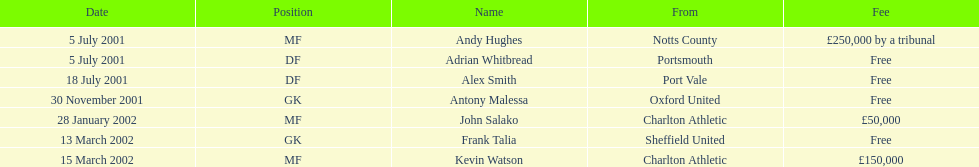Who shifted before 1 august 2001? Andy Hughes, Adrian Whitbread, Alex Smith. Would you be able to parse every entry in this table? {'header': ['Date', 'Position', 'Name', 'From', 'Fee'], 'rows': [['5 July 2001', 'MF', 'Andy Hughes', 'Notts County', '£250,000 by a tribunal'], ['5 July 2001', 'DF', 'Adrian Whitbread', 'Portsmouth', 'Free'], ['18 July 2001', 'DF', 'Alex Smith', 'Port Vale', 'Free'], ['30 November 2001', 'GK', 'Antony Malessa', 'Oxford United', 'Free'], ['28 January 2002', 'MF', 'John Salako', 'Charlton Athletic', '£50,000'], ['13 March 2002', 'GK', 'Frank Talia', 'Sheffield United', 'Free'], ['15 March 2002', 'MF', 'Kevin Watson', 'Charlton Athletic', '£150,000']]} 